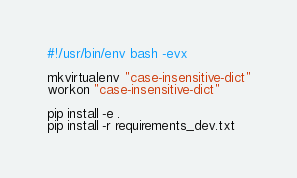Convert code to text. <code><loc_0><loc_0><loc_500><loc_500><_Bash_>#!/usr/bin/env bash -evx

mkvirtualenv "case-insensitive-dict"
workon "case-insensitive-dict"

pip install -e .
pip install -r requirements_dev.txt
</code> 